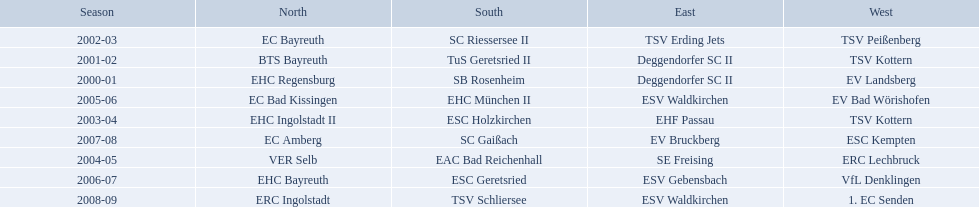Which teams played in the north? EHC Regensburg, BTS Bayreuth, EC Bayreuth, EHC Ingolstadt II, VER Selb, EC Bad Kissingen, EHC Bayreuth, EC Amberg, ERC Ingolstadt. Of these teams, which played during 2000-2001? EHC Regensburg. 